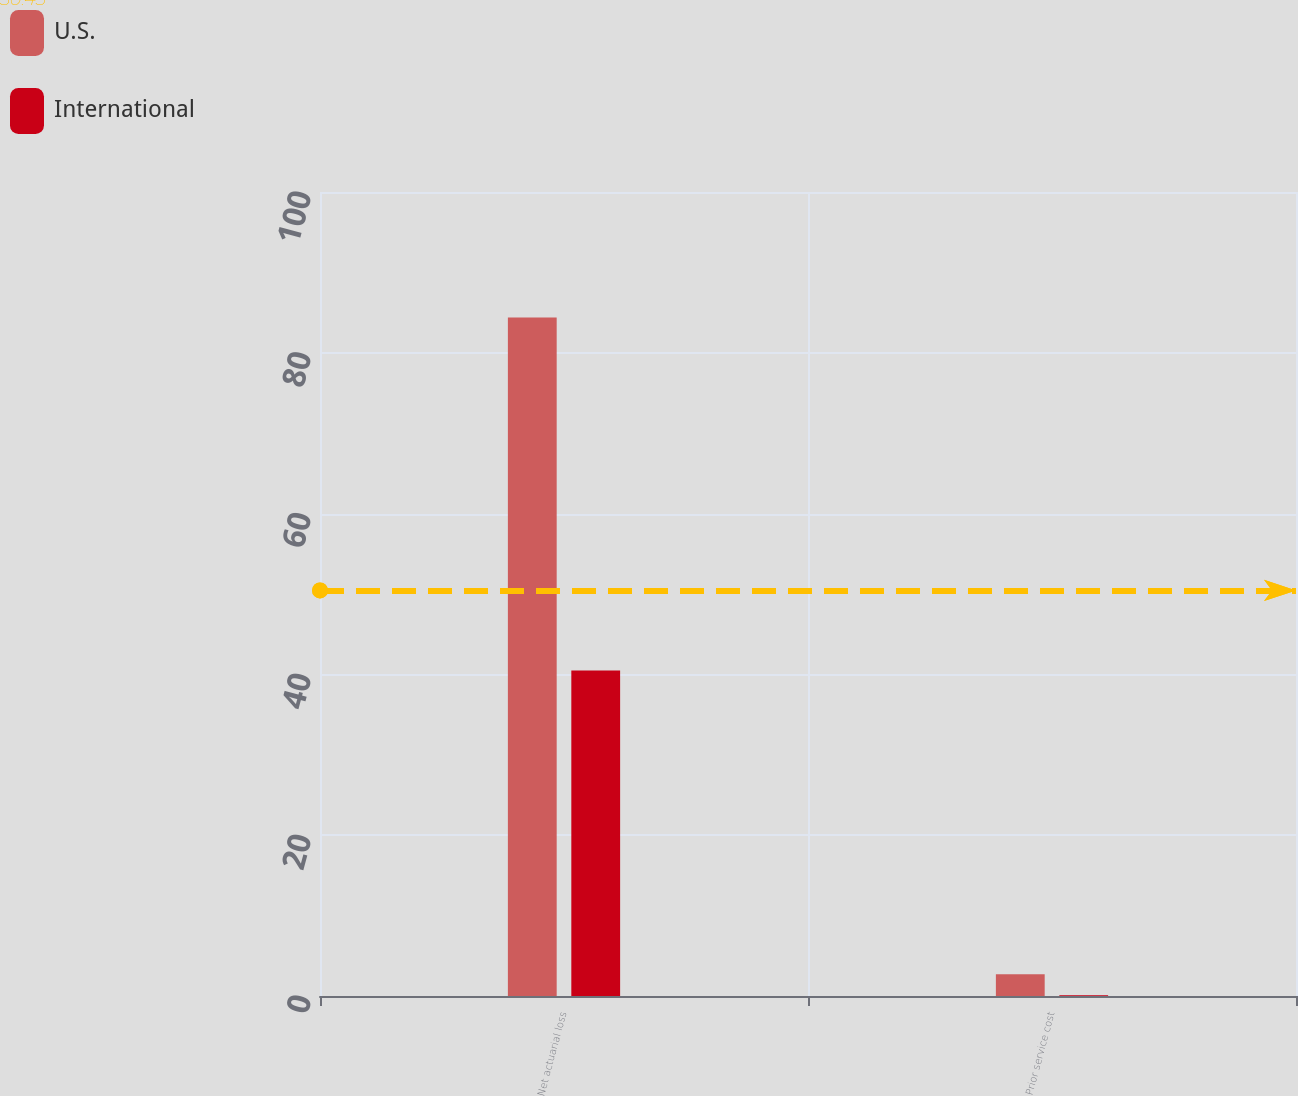Convert chart. <chart><loc_0><loc_0><loc_500><loc_500><stacked_bar_chart><ecel><fcel>Net actuarial loss<fcel>Prior service cost<nl><fcel>U.S.<fcel>84.4<fcel>2.7<nl><fcel>International<fcel>40.5<fcel>0.1<nl></chart> 